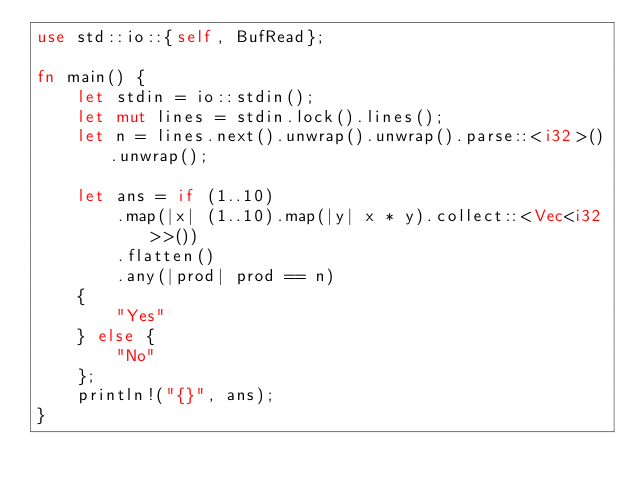Convert code to text. <code><loc_0><loc_0><loc_500><loc_500><_Rust_>use std::io::{self, BufRead};

fn main() {
    let stdin = io::stdin();
    let mut lines = stdin.lock().lines();
    let n = lines.next().unwrap().unwrap().parse::<i32>().unwrap();

    let ans = if (1..10)
        .map(|x| (1..10).map(|y| x * y).collect::<Vec<i32>>())
        .flatten()
        .any(|prod| prod == n)
    {
        "Yes"
    } else {
        "No"
    };
    println!("{}", ans);
}
</code> 